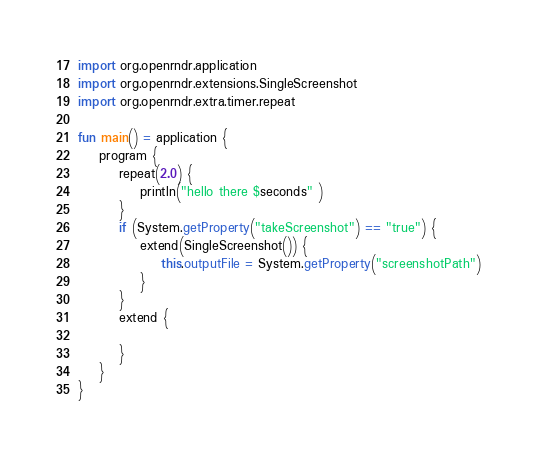Convert code to text. <code><loc_0><loc_0><loc_500><loc_500><_Kotlin_>import org.openrndr.application
import org.openrndr.extensions.SingleScreenshot
import org.openrndr.extra.timer.repeat

fun main() = application {
    program {
        repeat(2.0) {
            println("hello there $seconds" )
        }
        if (System.getProperty("takeScreenshot") == "true") {
            extend(SingleScreenshot()) {
                this.outputFile = System.getProperty("screenshotPath")
            }
        }
        extend {

        }
    }
}</code> 